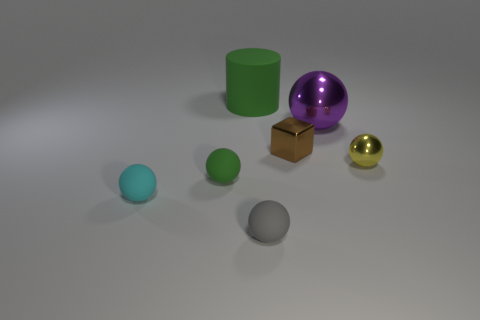Subtract all large purple balls. How many balls are left? 4 Subtract all yellow spheres. How many spheres are left? 4 Add 2 brown blocks. How many objects exist? 9 Subtract 3 balls. How many balls are left? 2 Subtract all spheres. How many objects are left? 2 Subtract all purple balls. Subtract all blue cubes. How many balls are left? 4 Subtract all gray rubber objects. Subtract all green rubber spheres. How many objects are left? 5 Add 5 tiny shiny balls. How many tiny shiny balls are left? 6 Add 5 small brown metal things. How many small brown metal things exist? 6 Subtract 0 brown cylinders. How many objects are left? 7 